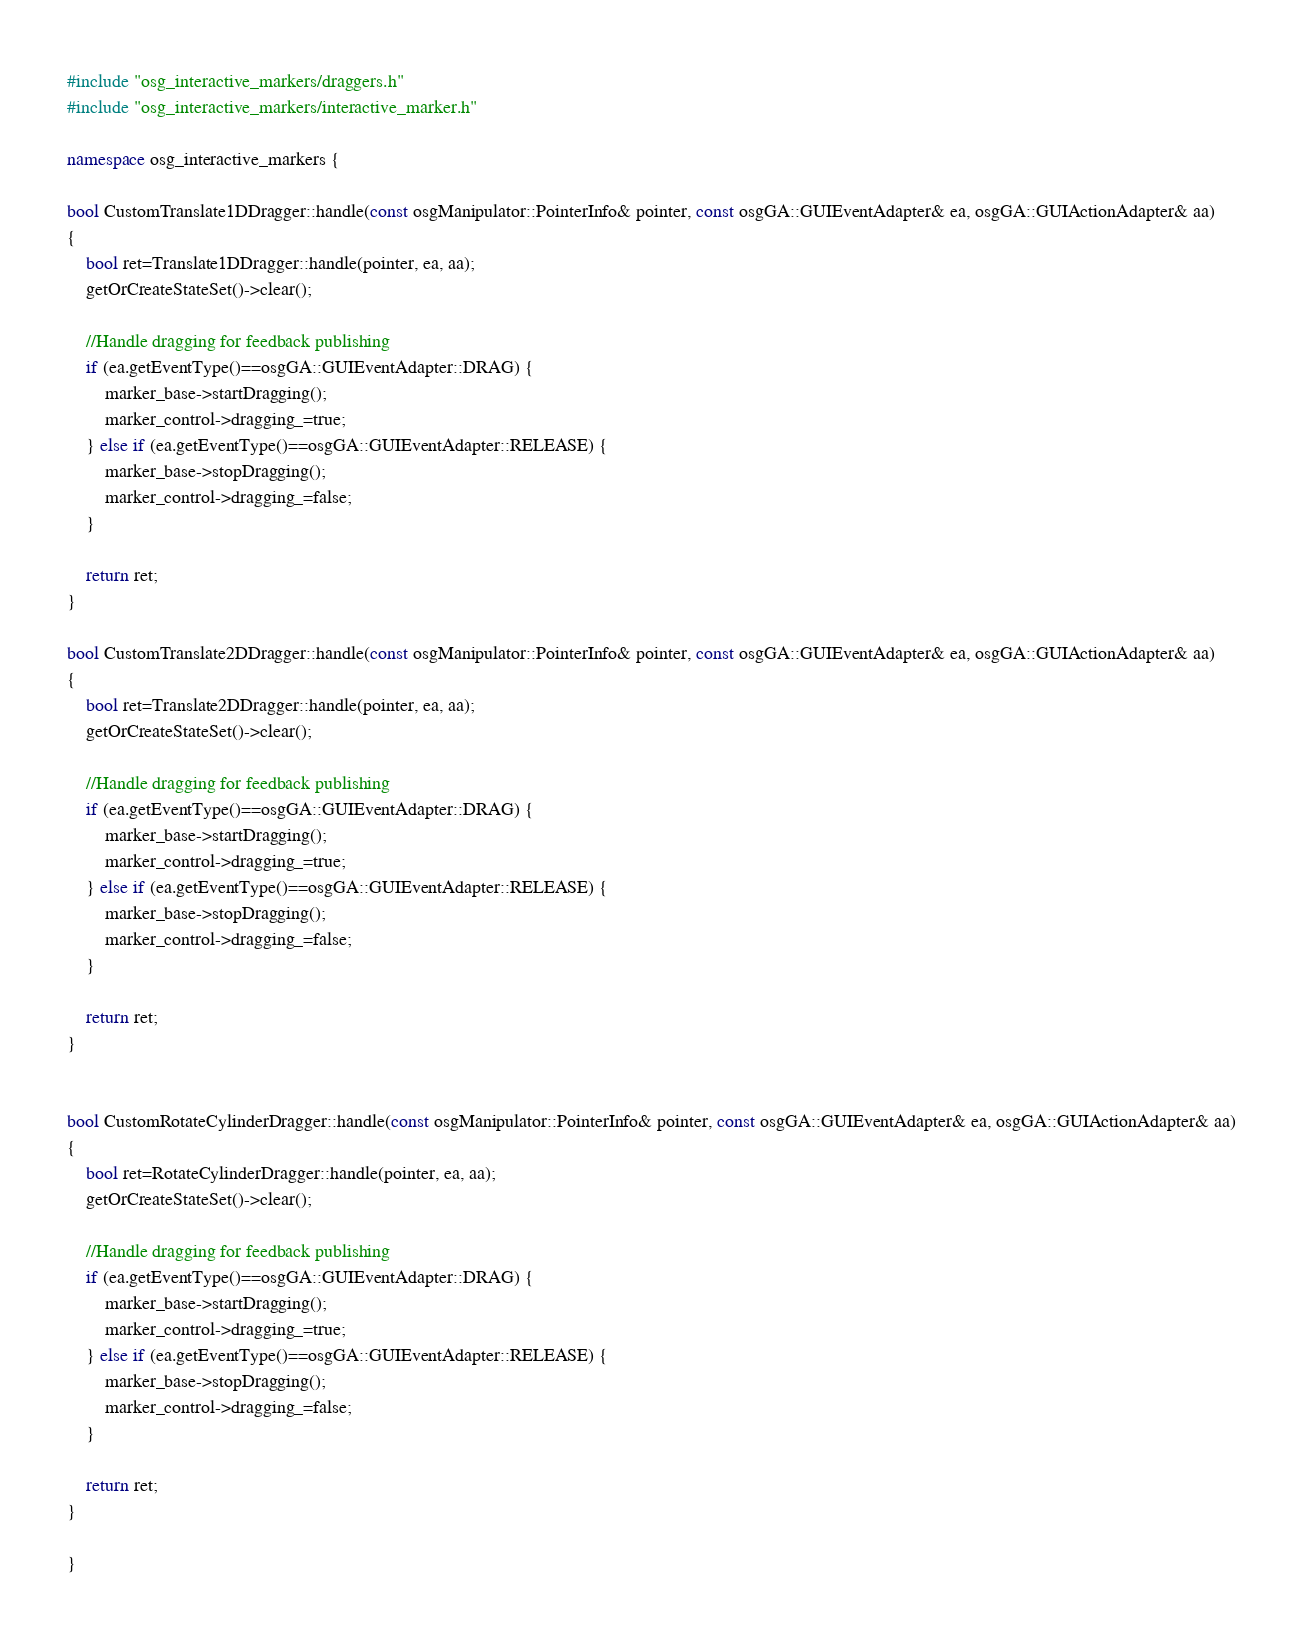Convert code to text. <code><loc_0><loc_0><loc_500><loc_500><_C++_>#include "osg_interactive_markers/draggers.h"
#include "osg_interactive_markers/interactive_marker.h"

namespace osg_interactive_markers {

bool CustomTranslate1DDragger::handle(const osgManipulator::PointerInfo& pointer, const osgGA::GUIEventAdapter& ea, osgGA::GUIActionAdapter& aa)
{
	bool ret=Translate1DDragger::handle(pointer, ea, aa);
	getOrCreateStateSet()->clear();

	//Handle dragging for feedback publishing
	if (ea.getEventType()==osgGA::GUIEventAdapter::DRAG) {
		marker_base->startDragging();
		marker_control->dragging_=true;
	} else if (ea.getEventType()==osgGA::GUIEventAdapter::RELEASE) {
		marker_base->stopDragging();
		marker_control->dragging_=false;
	}

	return ret;
}

bool CustomTranslate2DDragger::handle(const osgManipulator::PointerInfo& pointer, const osgGA::GUIEventAdapter& ea, osgGA::GUIActionAdapter& aa)
{
	bool ret=Translate2DDragger::handle(pointer, ea, aa);
	getOrCreateStateSet()->clear();

	//Handle dragging for feedback publishing
	if (ea.getEventType()==osgGA::GUIEventAdapter::DRAG) {
		marker_base->startDragging();
		marker_control->dragging_=true;
	} else if (ea.getEventType()==osgGA::GUIEventAdapter::RELEASE) {
		marker_base->stopDragging();
		marker_control->dragging_=false;
	}

	return ret;
}


bool CustomRotateCylinderDragger::handle(const osgManipulator::PointerInfo& pointer, const osgGA::GUIEventAdapter& ea, osgGA::GUIActionAdapter& aa)
{
	bool ret=RotateCylinderDragger::handle(pointer, ea, aa);
	getOrCreateStateSet()->clear();

	//Handle dragging for feedback publishing
	if (ea.getEventType()==osgGA::GUIEventAdapter::DRAG) {
		marker_base->startDragging();
		marker_control->dragging_=true;
	} else if (ea.getEventType()==osgGA::GUIEventAdapter::RELEASE) {
		marker_base->stopDragging();
		marker_control->dragging_=false;
	}

	return ret;
}

}
</code> 